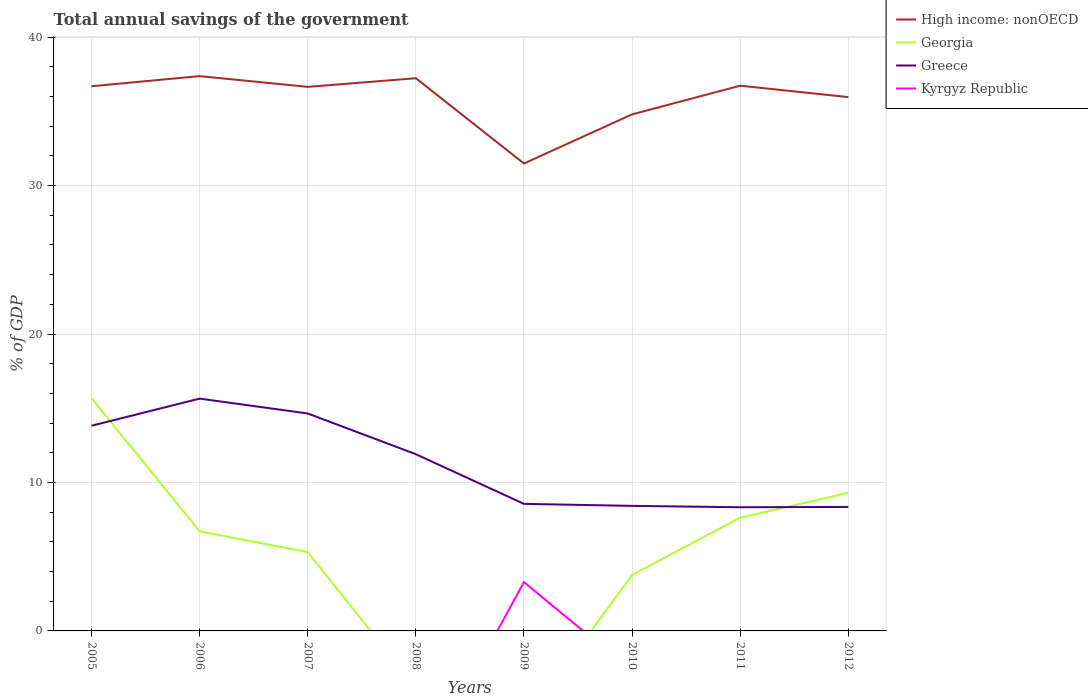How many different coloured lines are there?
Your response must be concise. 4. Does the line corresponding to Greece intersect with the line corresponding to Georgia?
Offer a terse response. Yes. Is the number of lines equal to the number of legend labels?
Give a very brief answer. No. Across all years, what is the maximum total annual savings of the government in Greece?
Give a very brief answer. 8.33. What is the total total annual savings of the government in Georgia in the graph?
Offer a terse response. 1.4. What is the difference between the highest and the second highest total annual savings of the government in Georgia?
Offer a terse response. 15.67. What is the difference between the highest and the lowest total annual savings of the government in Kyrgyz Republic?
Keep it short and to the point. 1. What is the difference between two consecutive major ticks on the Y-axis?
Keep it short and to the point. 10. Are the values on the major ticks of Y-axis written in scientific E-notation?
Provide a short and direct response. No. Does the graph contain any zero values?
Provide a succinct answer. Yes. What is the title of the graph?
Your response must be concise. Total annual savings of the government. What is the label or title of the X-axis?
Your answer should be compact. Years. What is the label or title of the Y-axis?
Provide a succinct answer. % of GDP. What is the % of GDP of High income: nonOECD in 2005?
Your answer should be very brief. 36.69. What is the % of GDP of Georgia in 2005?
Give a very brief answer. 15.67. What is the % of GDP of Greece in 2005?
Provide a short and direct response. 13.82. What is the % of GDP in Kyrgyz Republic in 2005?
Your answer should be very brief. 0. What is the % of GDP of High income: nonOECD in 2006?
Give a very brief answer. 37.37. What is the % of GDP of Georgia in 2006?
Offer a very short reply. 6.71. What is the % of GDP in Greece in 2006?
Offer a terse response. 15.65. What is the % of GDP of High income: nonOECD in 2007?
Your answer should be very brief. 36.65. What is the % of GDP of Georgia in 2007?
Offer a terse response. 5.31. What is the % of GDP of Greece in 2007?
Give a very brief answer. 14.65. What is the % of GDP of Kyrgyz Republic in 2007?
Ensure brevity in your answer.  0. What is the % of GDP of High income: nonOECD in 2008?
Your response must be concise. 37.23. What is the % of GDP of Georgia in 2008?
Your answer should be compact. 0. What is the % of GDP in Greece in 2008?
Provide a succinct answer. 11.9. What is the % of GDP in Kyrgyz Republic in 2008?
Your response must be concise. 0. What is the % of GDP in High income: nonOECD in 2009?
Your answer should be very brief. 31.49. What is the % of GDP in Greece in 2009?
Make the answer very short. 8.56. What is the % of GDP of Kyrgyz Republic in 2009?
Offer a very short reply. 3.29. What is the % of GDP of High income: nonOECD in 2010?
Offer a terse response. 34.8. What is the % of GDP in Georgia in 2010?
Offer a terse response. 3.77. What is the % of GDP of Greece in 2010?
Your response must be concise. 8.42. What is the % of GDP of Kyrgyz Republic in 2010?
Your answer should be compact. 0. What is the % of GDP of High income: nonOECD in 2011?
Your response must be concise. 36.73. What is the % of GDP in Georgia in 2011?
Provide a short and direct response. 7.63. What is the % of GDP in Greece in 2011?
Give a very brief answer. 8.33. What is the % of GDP of High income: nonOECD in 2012?
Your answer should be compact. 35.96. What is the % of GDP of Georgia in 2012?
Provide a succinct answer. 9.3. What is the % of GDP in Greece in 2012?
Ensure brevity in your answer.  8.35. What is the % of GDP in Kyrgyz Republic in 2012?
Offer a very short reply. 0. Across all years, what is the maximum % of GDP of High income: nonOECD?
Offer a very short reply. 37.37. Across all years, what is the maximum % of GDP of Georgia?
Give a very brief answer. 15.67. Across all years, what is the maximum % of GDP in Greece?
Ensure brevity in your answer.  15.65. Across all years, what is the maximum % of GDP in Kyrgyz Republic?
Keep it short and to the point. 3.29. Across all years, what is the minimum % of GDP in High income: nonOECD?
Keep it short and to the point. 31.49. Across all years, what is the minimum % of GDP of Greece?
Offer a terse response. 8.33. Across all years, what is the minimum % of GDP in Kyrgyz Republic?
Ensure brevity in your answer.  0. What is the total % of GDP in High income: nonOECD in the graph?
Offer a very short reply. 286.92. What is the total % of GDP of Georgia in the graph?
Give a very brief answer. 48.39. What is the total % of GDP of Greece in the graph?
Provide a succinct answer. 89.69. What is the total % of GDP of Kyrgyz Republic in the graph?
Your response must be concise. 3.29. What is the difference between the % of GDP in High income: nonOECD in 2005 and that in 2006?
Your answer should be compact. -0.68. What is the difference between the % of GDP in Georgia in 2005 and that in 2006?
Offer a very short reply. 8.96. What is the difference between the % of GDP in Greece in 2005 and that in 2006?
Your answer should be compact. -1.83. What is the difference between the % of GDP of High income: nonOECD in 2005 and that in 2007?
Provide a short and direct response. 0.04. What is the difference between the % of GDP in Georgia in 2005 and that in 2007?
Your answer should be compact. 10.36. What is the difference between the % of GDP of Greece in 2005 and that in 2007?
Make the answer very short. -0.82. What is the difference between the % of GDP in High income: nonOECD in 2005 and that in 2008?
Your answer should be very brief. -0.54. What is the difference between the % of GDP in Greece in 2005 and that in 2008?
Your answer should be very brief. 1.92. What is the difference between the % of GDP in High income: nonOECD in 2005 and that in 2009?
Make the answer very short. 5.2. What is the difference between the % of GDP in Greece in 2005 and that in 2009?
Offer a terse response. 5.26. What is the difference between the % of GDP in High income: nonOECD in 2005 and that in 2010?
Your answer should be compact. 1.9. What is the difference between the % of GDP of Georgia in 2005 and that in 2010?
Your response must be concise. 11.89. What is the difference between the % of GDP of Greece in 2005 and that in 2010?
Keep it short and to the point. 5.4. What is the difference between the % of GDP of High income: nonOECD in 2005 and that in 2011?
Offer a very short reply. -0.04. What is the difference between the % of GDP of Georgia in 2005 and that in 2011?
Your answer should be compact. 8.04. What is the difference between the % of GDP of Greece in 2005 and that in 2011?
Your answer should be very brief. 5.49. What is the difference between the % of GDP in High income: nonOECD in 2005 and that in 2012?
Give a very brief answer. 0.73. What is the difference between the % of GDP of Georgia in 2005 and that in 2012?
Your response must be concise. 6.37. What is the difference between the % of GDP of Greece in 2005 and that in 2012?
Offer a terse response. 5.47. What is the difference between the % of GDP of High income: nonOECD in 2006 and that in 2007?
Your answer should be very brief. 0.72. What is the difference between the % of GDP of Georgia in 2006 and that in 2007?
Offer a very short reply. 1.4. What is the difference between the % of GDP of Greece in 2006 and that in 2007?
Offer a very short reply. 1. What is the difference between the % of GDP of High income: nonOECD in 2006 and that in 2008?
Provide a succinct answer. 0.14. What is the difference between the % of GDP in Greece in 2006 and that in 2008?
Give a very brief answer. 3.75. What is the difference between the % of GDP of High income: nonOECD in 2006 and that in 2009?
Make the answer very short. 5.89. What is the difference between the % of GDP of Greece in 2006 and that in 2009?
Your response must be concise. 7.09. What is the difference between the % of GDP of High income: nonOECD in 2006 and that in 2010?
Offer a terse response. 2.58. What is the difference between the % of GDP of Georgia in 2006 and that in 2010?
Keep it short and to the point. 2.93. What is the difference between the % of GDP of Greece in 2006 and that in 2010?
Keep it short and to the point. 7.23. What is the difference between the % of GDP in High income: nonOECD in 2006 and that in 2011?
Provide a short and direct response. 0.64. What is the difference between the % of GDP in Georgia in 2006 and that in 2011?
Give a very brief answer. -0.92. What is the difference between the % of GDP in Greece in 2006 and that in 2011?
Make the answer very short. 7.32. What is the difference between the % of GDP in High income: nonOECD in 2006 and that in 2012?
Make the answer very short. 1.41. What is the difference between the % of GDP in Georgia in 2006 and that in 2012?
Offer a very short reply. -2.6. What is the difference between the % of GDP of Greece in 2006 and that in 2012?
Keep it short and to the point. 7.3. What is the difference between the % of GDP in High income: nonOECD in 2007 and that in 2008?
Offer a terse response. -0.58. What is the difference between the % of GDP in Greece in 2007 and that in 2008?
Give a very brief answer. 2.74. What is the difference between the % of GDP of High income: nonOECD in 2007 and that in 2009?
Offer a very short reply. 5.16. What is the difference between the % of GDP in Greece in 2007 and that in 2009?
Provide a succinct answer. 6.09. What is the difference between the % of GDP of High income: nonOECD in 2007 and that in 2010?
Your answer should be very brief. 1.85. What is the difference between the % of GDP of Georgia in 2007 and that in 2010?
Keep it short and to the point. 1.54. What is the difference between the % of GDP in Greece in 2007 and that in 2010?
Provide a short and direct response. 6.22. What is the difference between the % of GDP of High income: nonOECD in 2007 and that in 2011?
Ensure brevity in your answer.  -0.08. What is the difference between the % of GDP of Georgia in 2007 and that in 2011?
Your answer should be compact. -2.32. What is the difference between the % of GDP in Greece in 2007 and that in 2011?
Provide a succinct answer. 6.32. What is the difference between the % of GDP in High income: nonOECD in 2007 and that in 2012?
Ensure brevity in your answer.  0.69. What is the difference between the % of GDP of Georgia in 2007 and that in 2012?
Ensure brevity in your answer.  -3.99. What is the difference between the % of GDP of Greece in 2007 and that in 2012?
Provide a succinct answer. 6.29. What is the difference between the % of GDP of High income: nonOECD in 2008 and that in 2009?
Your answer should be very brief. 5.74. What is the difference between the % of GDP in Greece in 2008 and that in 2009?
Make the answer very short. 3.35. What is the difference between the % of GDP of High income: nonOECD in 2008 and that in 2010?
Your answer should be very brief. 2.44. What is the difference between the % of GDP in Greece in 2008 and that in 2010?
Your response must be concise. 3.48. What is the difference between the % of GDP in High income: nonOECD in 2008 and that in 2011?
Provide a short and direct response. 0.5. What is the difference between the % of GDP in Greece in 2008 and that in 2011?
Keep it short and to the point. 3.57. What is the difference between the % of GDP of High income: nonOECD in 2008 and that in 2012?
Make the answer very short. 1.27. What is the difference between the % of GDP in Greece in 2008 and that in 2012?
Provide a short and direct response. 3.55. What is the difference between the % of GDP of High income: nonOECD in 2009 and that in 2010?
Provide a succinct answer. -3.31. What is the difference between the % of GDP of Greece in 2009 and that in 2010?
Your answer should be compact. 0.13. What is the difference between the % of GDP of High income: nonOECD in 2009 and that in 2011?
Provide a short and direct response. -5.24. What is the difference between the % of GDP in Greece in 2009 and that in 2011?
Ensure brevity in your answer.  0.23. What is the difference between the % of GDP in High income: nonOECD in 2009 and that in 2012?
Ensure brevity in your answer.  -4.47. What is the difference between the % of GDP in Greece in 2009 and that in 2012?
Your response must be concise. 0.2. What is the difference between the % of GDP of High income: nonOECD in 2010 and that in 2011?
Your answer should be compact. -1.93. What is the difference between the % of GDP of Georgia in 2010 and that in 2011?
Provide a succinct answer. -3.85. What is the difference between the % of GDP in Greece in 2010 and that in 2011?
Your answer should be compact. 0.09. What is the difference between the % of GDP in High income: nonOECD in 2010 and that in 2012?
Give a very brief answer. -1.17. What is the difference between the % of GDP in Georgia in 2010 and that in 2012?
Give a very brief answer. -5.53. What is the difference between the % of GDP of Greece in 2010 and that in 2012?
Provide a short and direct response. 0.07. What is the difference between the % of GDP in High income: nonOECD in 2011 and that in 2012?
Your response must be concise. 0.77. What is the difference between the % of GDP of Georgia in 2011 and that in 2012?
Keep it short and to the point. -1.68. What is the difference between the % of GDP in Greece in 2011 and that in 2012?
Make the answer very short. -0.02. What is the difference between the % of GDP in High income: nonOECD in 2005 and the % of GDP in Georgia in 2006?
Ensure brevity in your answer.  29.98. What is the difference between the % of GDP of High income: nonOECD in 2005 and the % of GDP of Greece in 2006?
Make the answer very short. 21.04. What is the difference between the % of GDP in Georgia in 2005 and the % of GDP in Greece in 2006?
Keep it short and to the point. 0.02. What is the difference between the % of GDP in High income: nonOECD in 2005 and the % of GDP in Georgia in 2007?
Give a very brief answer. 31.38. What is the difference between the % of GDP in High income: nonOECD in 2005 and the % of GDP in Greece in 2007?
Offer a terse response. 22.04. What is the difference between the % of GDP in Georgia in 2005 and the % of GDP in Greece in 2007?
Provide a short and direct response. 1.02. What is the difference between the % of GDP in High income: nonOECD in 2005 and the % of GDP in Greece in 2008?
Offer a very short reply. 24.79. What is the difference between the % of GDP in Georgia in 2005 and the % of GDP in Greece in 2008?
Your answer should be very brief. 3.76. What is the difference between the % of GDP of High income: nonOECD in 2005 and the % of GDP of Greece in 2009?
Give a very brief answer. 28.13. What is the difference between the % of GDP in High income: nonOECD in 2005 and the % of GDP in Kyrgyz Republic in 2009?
Offer a terse response. 33.4. What is the difference between the % of GDP of Georgia in 2005 and the % of GDP of Greece in 2009?
Give a very brief answer. 7.11. What is the difference between the % of GDP in Georgia in 2005 and the % of GDP in Kyrgyz Republic in 2009?
Make the answer very short. 12.38. What is the difference between the % of GDP in Greece in 2005 and the % of GDP in Kyrgyz Republic in 2009?
Your answer should be very brief. 10.54. What is the difference between the % of GDP of High income: nonOECD in 2005 and the % of GDP of Georgia in 2010?
Your answer should be compact. 32.92. What is the difference between the % of GDP in High income: nonOECD in 2005 and the % of GDP in Greece in 2010?
Offer a very short reply. 28.27. What is the difference between the % of GDP of Georgia in 2005 and the % of GDP of Greece in 2010?
Ensure brevity in your answer.  7.24. What is the difference between the % of GDP of High income: nonOECD in 2005 and the % of GDP of Georgia in 2011?
Provide a short and direct response. 29.07. What is the difference between the % of GDP of High income: nonOECD in 2005 and the % of GDP of Greece in 2011?
Your answer should be very brief. 28.36. What is the difference between the % of GDP of Georgia in 2005 and the % of GDP of Greece in 2011?
Ensure brevity in your answer.  7.34. What is the difference between the % of GDP in High income: nonOECD in 2005 and the % of GDP in Georgia in 2012?
Your answer should be compact. 27.39. What is the difference between the % of GDP in High income: nonOECD in 2005 and the % of GDP in Greece in 2012?
Your response must be concise. 28.34. What is the difference between the % of GDP of Georgia in 2005 and the % of GDP of Greece in 2012?
Your response must be concise. 7.31. What is the difference between the % of GDP of High income: nonOECD in 2006 and the % of GDP of Georgia in 2007?
Your answer should be compact. 32.06. What is the difference between the % of GDP of High income: nonOECD in 2006 and the % of GDP of Greece in 2007?
Offer a very short reply. 22.73. What is the difference between the % of GDP of Georgia in 2006 and the % of GDP of Greece in 2007?
Make the answer very short. -7.94. What is the difference between the % of GDP in High income: nonOECD in 2006 and the % of GDP in Greece in 2008?
Ensure brevity in your answer.  25.47. What is the difference between the % of GDP of Georgia in 2006 and the % of GDP of Greece in 2008?
Provide a succinct answer. -5.2. What is the difference between the % of GDP of High income: nonOECD in 2006 and the % of GDP of Greece in 2009?
Make the answer very short. 28.82. What is the difference between the % of GDP of High income: nonOECD in 2006 and the % of GDP of Kyrgyz Republic in 2009?
Keep it short and to the point. 34.09. What is the difference between the % of GDP of Georgia in 2006 and the % of GDP of Greece in 2009?
Give a very brief answer. -1.85. What is the difference between the % of GDP of Georgia in 2006 and the % of GDP of Kyrgyz Republic in 2009?
Your answer should be compact. 3.42. What is the difference between the % of GDP of Greece in 2006 and the % of GDP of Kyrgyz Republic in 2009?
Ensure brevity in your answer.  12.36. What is the difference between the % of GDP in High income: nonOECD in 2006 and the % of GDP in Georgia in 2010?
Your answer should be very brief. 33.6. What is the difference between the % of GDP of High income: nonOECD in 2006 and the % of GDP of Greece in 2010?
Provide a succinct answer. 28.95. What is the difference between the % of GDP in Georgia in 2006 and the % of GDP in Greece in 2010?
Make the answer very short. -1.72. What is the difference between the % of GDP of High income: nonOECD in 2006 and the % of GDP of Georgia in 2011?
Offer a terse response. 29.75. What is the difference between the % of GDP in High income: nonOECD in 2006 and the % of GDP in Greece in 2011?
Provide a succinct answer. 29.04. What is the difference between the % of GDP in Georgia in 2006 and the % of GDP in Greece in 2011?
Keep it short and to the point. -1.62. What is the difference between the % of GDP in High income: nonOECD in 2006 and the % of GDP in Georgia in 2012?
Offer a terse response. 28.07. What is the difference between the % of GDP of High income: nonOECD in 2006 and the % of GDP of Greece in 2012?
Your response must be concise. 29.02. What is the difference between the % of GDP of Georgia in 2006 and the % of GDP of Greece in 2012?
Give a very brief answer. -1.65. What is the difference between the % of GDP of High income: nonOECD in 2007 and the % of GDP of Greece in 2008?
Offer a very short reply. 24.75. What is the difference between the % of GDP of Georgia in 2007 and the % of GDP of Greece in 2008?
Make the answer very short. -6.59. What is the difference between the % of GDP of High income: nonOECD in 2007 and the % of GDP of Greece in 2009?
Give a very brief answer. 28.09. What is the difference between the % of GDP of High income: nonOECD in 2007 and the % of GDP of Kyrgyz Republic in 2009?
Make the answer very short. 33.36. What is the difference between the % of GDP in Georgia in 2007 and the % of GDP in Greece in 2009?
Keep it short and to the point. -3.25. What is the difference between the % of GDP in Georgia in 2007 and the % of GDP in Kyrgyz Republic in 2009?
Ensure brevity in your answer.  2.02. What is the difference between the % of GDP in Greece in 2007 and the % of GDP in Kyrgyz Republic in 2009?
Offer a terse response. 11.36. What is the difference between the % of GDP of High income: nonOECD in 2007 and the % of GDP of Georgia in 2010?
Provide a short and direct response. 32.88. What is the difference between the % of GDP in High income: nonOECD in 2007 and the % of GDP in Greece in 2010?
Your answer should be compact. 28.23. What is the difference between the % of GDP of Georgia in 2007 and the % of GDP of Greece in 2010?
Your response must be concise. -3.11. What is the difference between the % of GDP in High income: nonOECD in 2007 and the % of GDP in Georgia in 2011?
Provide a short and direct response. 29.02. What is the difference between the % of GDP of High income: nonOECD in 2007 and the % of GDP of Greece in 2011?
Offer a terse response. 28.32. What is the difference between the % of GDP in Georgia in 2007 and the % of GDP in Greece in 2011?
Offer a terse response. -3.02. What is the difference between the % of GDP in High income: nonOECD in 2007 and the % of GDP in Georgia in 2012?
Offer a very short reply. 27.35. What is the difference between the % of GDP of High income: nonOECD in 2007 and the % of GDP of Greece in 2012?
Your response must be concise. 28.3. What is the difference between the % of GDP in Georgia in 2007 and the % of GDP in Greece in 2012?
Give a very brief answer. -3.04. What is the difference between the % of GDP in High income: nonOECD in 2008 and the % of GDP in Greece in 2009?
Your response must be concise. 28.67. What is the difference between the % of GDP of High income: nonOECD in 2008 and the % of GDP of Kyrgyz Republic in 2009?
Give a very brief answer. 33.94. What is the difference between the % of GDP in Greece in 2008 and the % of GDP in Kyrgyz Republic in 2009?
Give a very brief answer. 8.62. What is the difference between the % of GDP in High income: nonOECD in 2008 and the % of GDP in Georgia in 2010?
Keep it short and to the point. 33.46. What is the difference between the % of GDP in High income: nonOECD in 2008 and the % of GDP in Greece in 2010?
Offer a terse response. 28.81. What is the difference between the % of GDP in High income: nonOECD in 2008 and the % of GDP in Georgia in 2011?
Your answer should be compact. 29.61. What is the difference between the % of GDP in High income: nonOECD in 2008 and the % of GDP in Greece in 2011?
Make the answer very short. 28.9. What is the difference between the % of GDP in High income: nonOECD in 2008 and the % of GDP in Georgia in 2012?
Provide a succinct answer. 27.93. What is the difference between the % of GDP of High income: nonOECD in 2008 and the % of GDP of Greece in 2012?
Your response must be concise. 28.88. What is the difference between the % of GDP in High income: nonOECD in 2009 and the % of GDP in Georgia in 2010?
Provide a succinct answer. 27.71. What is the difference between the % of GDP in High income: nonOECD in 2009 and the % of GDP in Greece in 2010?
Give a very brief answer. 23.06. What is the difference between the % of GDP in High income: nonOECD in 2009 and the % of GDP in Georgia in 2011?
Provide a short and direct response. 23.86. What is the difference between the % of GDP of High income: nonOECD in 2009 and the % of GDP of Greece in 2011?
Provide a short and direct response. 23.16. What is the difference between the % of GDP in High income: nonOECD in 2009 and the % of GDP in Georgia in 2012?
Give a very brief answer. 22.19. What is the difference between the % of GDP in High income: nonOECD in 2009 and the % of GDP in Greece in 2012?
Make the answer very short. 23.13. What is the difference between the % of GDP in High income: nonOECD in 2010 and the % of GDP in Georgia in 2011?
Your answer should be compact. 27.17. What is the difference between the % of GDP in High income: nonOECD in 2010 and the % of GDP in Greece in 2011?
Your answer should be compact. 26.47. What is the difference between the % of GDP in Georgia in 2010 and the % of GDP in Greece in 2011?
Offer a very short reply. -4.56. What is the difference between the % of GDP in High income: nonOECD in 2010 and the % of GDP in Georgia in 2012?
Keep it short and to the point. 25.49. What is the difference between the % of GDP of High income: nonOECD in 2010 and the % of GDP of Greece in 2012?
Give a very brief answer. 26.44. What is the difference between the % of GDP in Georgia in 2010 and the % of GDP in Greece in 2012?
Give a very brief answer. -4.58. What is the difference between the % of GDP in High income: nonOECD in 2011 and the % of GDP in Georgia in 2012?
Your response must be concise. 27.43. What is the difference between the % of GDP in High income: nonOECD in 2011 and the % of GDP in Greece in 2012?
Provide a short and direct response. 28.38. What is the difference between the % of GDP in Georgia in 2011 and the % of GDP in Greece in 2012?
Keep it short and to the point. -0.73. What is the average % of GDP of High income: nonOECD per year?
Offer a terse response. 35.87. What is the average % of GDP in Georgia per year?
Ensure brevity in your answer.  6.05. What is the average % of GDP of Greece per year?
Ensure brevity in your answer.  11.21. What is the average % of GDP in Kyrgyz Republic per year?
Your answer should be very brief. 0.41. In the year 2005, what is the difference between the % of GDP in High income: nonOECD and % of GDP in Georgia?
Your answer should be compact. 21.02. In the year 2005, what is the difference between the % of GDP in High income: nonOECD and % of GDP in Greece?
Your answer should be compact. 22.87. In the year 2005, what is the difference between the % of GDP of Georgia and % of GDP of Greece?
Offer a very short reply. 1.84. In the year 2006, what is the difference between the % of GDP in High income: nonOECD and % of GDP in Georgia?
Your answer should be very brief. 30.67. In the year 2006, what is the difference between the % of GDP in High income: nonOECD and % of GDP in Greece?
Your answer should be compact. 21.72. In the year 2006, what is the difference between the % of GDP in Georgia and % of GDP in Greece?
Provide a succinct answer. -8.94. In the year 2007, what is the difference between the % of GDP of High income: nonOECD and % of GDP of Georgia?
Make the answer very short. 31.34. In the year 2007, what is the difference between the % of GDP in High income: nonOECD and % of GDP in Greece?
Provide a succinct answer. 22. In the year 2007, what is the difference between the % of GDP in Georgia and % of GDP in Greece?
Provide a succinct answer. -9.34. In the year 2008, what is the difference between the % of GDP in High income: nonOECD and % of GDP in Greece?
Offer a terse response. 25.33. In the year 2009, what is the difference between the % of GDP of High income: nonOECD and % of GDP of Greece?
Provide a short and direct response. 22.93. In the year 2009, what is the difference between the % of GDP in High income: nonOECD and % of GDP in Kyrgyz Republic?
Keep it short and to the point. 28.2. In the year 2009, what is the difference between the % of GDP of Greece and % of GDP of Kyrgyz Republic?
Your response must be concise. 5.27. In the year 2010, what is the difference between the % of GDP in High income: nonOECD and % of GDP in Georgia?
Provide a short and direct response. 31.02. In the year 2010, what is the difference between the % of GDP in High income: nonOECD and % of GDP in Greece?
Your response must be concise. 26.37. In the year 2010, what is the difference between the % of GDP in Georgia and % of GDP in Greece?
Provide a short and direct response. -4.65. In the year 2011, what is the difference between the % of GDP in High income: nonOECD and % of GDP in Georgia?
Offer a terse response. 29.1. In the year 2011, what is the difference between the % of GDP in High income: nonOECD and % of GDP in Greece?
Provide a short and direct response. 28.4. In the year 2011, what is the difference between the % of GDP of Georgia and % of GDP of Greece?
Offer a very short reply. -0.7. In the year 2012, what is the difference between the % of GDP in High income: nonOECD and % of GDP in Georgia?
Your answer should be compact. 26.66. In the year 2012, what is the difference between the % of GDP in High income: nonOECD and % of GDP in Greece?
Your answer should be very brief. 27.61. In the year 2012, what is the difference between the % of GDP of Georgia and % of GDP of Greece?
Provide a short and direct response. 0.95. What is the ratio of the % of GDP of High income: nonOECD in 2005 to that in 2006?
Keep it short and to the point. 0.98. What is the ratio of the % of GDP of Georgia in 2005 to that in 2006?
Offer a terse response. 2.34. What is the ratio of the % of GDP in Greece in 2005 to that in 2006?
Provide a short and direct response. 0.88. What is the ratio of the % of GDP of Georgia in 2005 to that in 2007?
Make the answer very short. 2.95. What is the ratio of the % of GDP of Greece in 2005 to that in 2007?
Your response must be concise. 0.94. What is the ratio of the % of GDP in High income: nonOECD in 2005 to that in 2008?
Ensure brevity in your answer.  0.99. What is the ratio of the % of GDP in Greece in 2005 to that in 2008?
Your answer should be very brief. 1.16. What is the ratio of the % of GDP of High income: nonOECD in 2005 to that in 2009?
Offer a very short reply. 1.17. What is the ratio of the % of GDP of Greece in 2005 to that in 2009?
Provide a succinct answer. 1.62. What is the ratio of the % of GDP in High income: nonOECD in 2005 to that in 2010?
Your answer should be very brief. 1.05. What is the ratio of the % of GDP of Georgia in 2005 to that in 2010?
Provide a short and direct response. 4.15. What is the ratio of the % of GDP of Greece in 2005 to that in 2010?
Your answer should be very brief. 1.64. What is the ratio of the % of GDP of Georgia in 2005 to that in 2011?
Your answer should be compact. 2.05. What is the ratio of the % of GDP in Greece in 2005 to that in 2011?
Keep it short and to the point. 1.66. What is the ratio of the % of GDP of High income: nonOECD in 2005 to that in 2012?
Make the answer very short. 1.02. What is the ratio of the % of GDP of Georgia in 2005 to that in 2012?
Make the answer very short. 1.68. What is the ratio of the % of GDP in Greece in 2005 to that in 2012?
Your response must be concise. 1.65. What is the ratio of the % of GDP in High income: nonOECD in 2006 to that in 2007?
Provide a succinct answer. 1.02. What is the ratio of the % of GDP of Georgia in 2006 to that in 2007?
Your answer should be very brief. 1.26. What is the ratio of the % of GDP of Greece in 2006 to that in 2007?
Give a very brief answer. 1.07. What is the ratio of the % of GDP in Greece in 2006 to that in 2008?
Give a very brief answer. 1.31. What is the ratio of the % of GDP in High income: nonOECD in 2006 to that in 2009?
Offer a terse response. 1.19. What is the ratio of the % of GDP of Greece in 2006 to that in 2009?
Ensure brevity in your answer.  1.83. What is the ratio of the % of GDP of High income: nonOECD in 2006 to that in 2010?
Your answer should be very brief. 1.07. What is the ratio of the % of GDP of Georgia in 2006 to that in 2010?
Give a very brief answer. 1.78. What is the ratio of the % of GDP of Greece in 2006 to that in 2010?
Give a very brief answer. 1.86. What is the ratio of the % of GDP of High income: nonOECD in 2006 to that in 2011?
Offer a terse response. 1.02. What is the ratio of the % of GDP of Georgia in 2006 to that in 2011?
Your answer should be compact. 0.88. What is the ratio of the % of GDP of Greece in 2006 to that in 2011?
Provide a succinct answer. 1.88. What is the ratio of the % of GDP of High income: nonOECD in 2006 to that in 2012?
Keep it short and to the point. 1.04. What is the ratio of the % of GDP in Georgia in 2006 to that in 2012?
Your answer should be very brief. 0.72. What is the ratio of the % of GDP in Greece in 2006 to that in 2012?
Provide a succinct answer. 1.87. What is the ratio of the % of GDP of High income: nonOECD in 2007 to that in 2008?
Offer a very short reply. 0.98. What is the ratio of the % of GDP in Greece in 2007 to that in 2008?
Your answer should be compact. 1.23. What is the ratio of the % of GDP in High income: nonOECD in 2007 to that in 2009?
Your answer should be very brief. 1.16. What is the ratio of the % of GDP in Greece in 2007 to that in 2009?
Your answer should be compact. 1.71. What is the ratio of the % of GDP of High income: nonOECD in 2007 to that in 2010?
Provide a succinct answer. 1.05. What is the ratio of the % of GDP of Georgia in 2007 to that in 2010?
Make the answer very short. 1.41. What is the ratio of the % of GDP in Greece in 2007 to that in 2010?
Provide a short and direct response. 1.74. What is the ratio of the % of GDP in High income: nonOECD in 2007 to that in 2011?
Offer a terse response. 1. What is the ratio of the % of GDP in Georgia in 2007 to that in 2011?
Make the answer very short. 0.7. What is the ratio of the % of GDP in Greece in 2007 to that in 2011?
Your response must be concise. 1.76. What is the ratio of the % of GDP in High income: nonOECD in 2007 to that in 2012?
Make the answer very short. 1.02. What is the ratio of the % of GDP in Georgia in 2007 to that in 2012?
Give a very brief answer. 0.57. What is the ratio of the % of GDP of Greece in 2007 to that in 2012?
Offer a terse response. 1.75. What is the ratio of the % of GDP in High income: nonOECD in 2008 to that in 2009?
Offer a terse response. 1.18. What is the ratio of the % of GDP of Greece in 2008 to that in 2009?
Provide a short and direct response. 1.39. What is the ratio of the % of GDP of High income: nonOECD in 2008 to that in 2010?
Give a very brief answer. 1.07. What is the ratio of the % of GDP of Greece in 2008 to that in 2010?
Offer a very short reply. 1.41. What is the ratio of the % of GDP in High income: nonOECD in 2008 to that in 2011?
Offer a terse response. 1.01. What is the ratio of the % of GDP of Greece in 2008 to that in 2011?
Make the answer very short. 1.43. What is the ratio of the % of GDP of High income: nonOECD in 2008 to that in 2012?
Ensure brevity in your answer.  1.04. What is the ratio of the % of GDP of Greece in 2008 to that in 2012?
Offer a very short reply. 1.43. What is the ratio of the % of GDP in High income: nonOECD in 2009 to that in 2010?
Provide a short and direct response. 0.9. What is the ratio of the % of GDP of High income: nonOECD in 2009 to that in 2011?
Provide a short and direct response. 0.86. What is the ratio of the % of GDP of Greece in 2009 to that in 2011?
Provide a succinct answer. 1.03. What is the ratio of the % of GDP in High income: nonOECD in 2009 to that in 2012?
Offer a very short reply. 0.88. What is the ratio of the % of GDP in Greece in 2009 to that in 2012?
Offer a terse response. 1.02. What is the ratio of the % of GDP of Georgia in 2010 to that in 2011?
Keep it short and to the point. 0.49. What is the ratio of the % of GDP in Greece in 2010 to that in 2011?
Your answer should be very brief. 1.01. What is the ratio of the % of GDP of High income: nonOECD in 2010 to that in 2012?
Make the answer very short. 0.97. What is the ratio of the % of GDP in Georgia in 2010 to that in 2012?
Your answer should be compact. 0.41. What is the ratio of the % of GDP in Greece in 2010 to that in 2012?
Your answer should be compact. 1.01. What is the ratio of the % of GDP of High income: nonOECD in 2011 to that in 2012?
Provide a succinct answer. 1.02. What is the ratio of the % of GDP in Georgia in 2011 to that in 2012?
Offer a terse response. 0.82. What is the difference between the highest and the second highest % of GDP in High income: nonOECD?
Your response must be concise. 0.14. What is the difference between the highest and the second highest % of GDP of Georgia?
Offer a very short reply. 6.37. What is the difference between the highest and the lowest % of GDP of High income: nonOECD?
Make the answer very short. 5.89. What is the difference between the highest and the lowest % of GDP in Georgia?
Give a very brief answer. 15.67. What is the difference between the highest and the lowest % of GDP in Greece?
Keep it short and to the point. 7.32. What is the difference between the highest and the lowest % of GDP in Kyrgyz Republic?
Offer a very short reply. 3.29. 